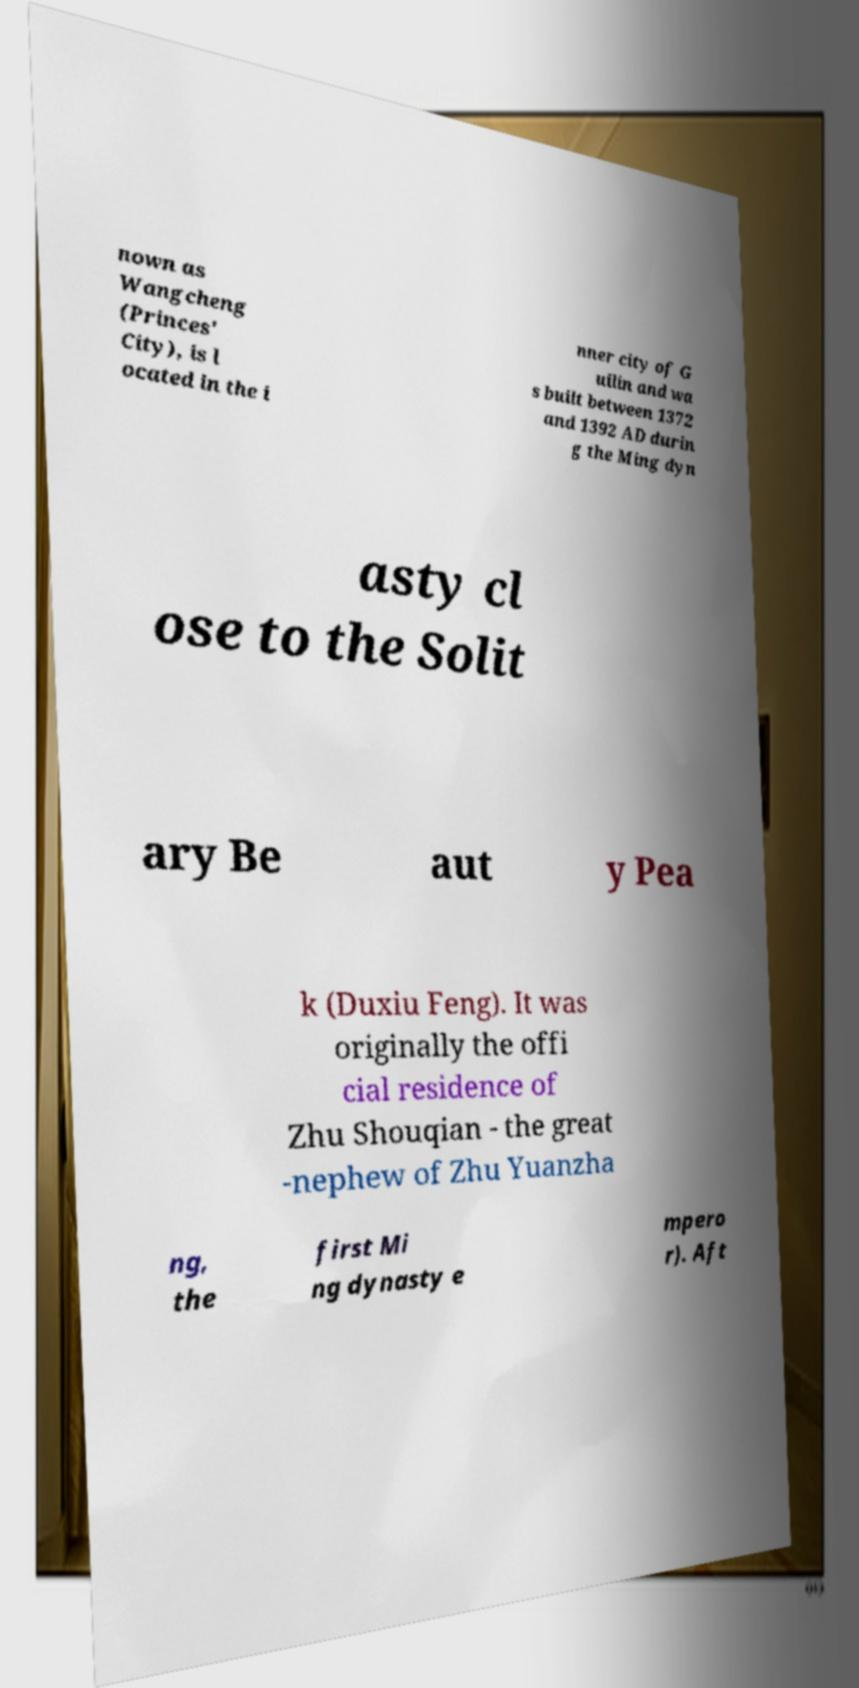There's text embedded in this image that I need extracted. Can you transcribe it verbatim? nown as Wangcheng (Princes' City), is l ocated in the i nner city of G uilin and wa s built between 1372 and 1392 AD durin g the Ming dyn asty cl ose to the Solit ary Be aut y Pea k (Duxiu Feng). It was originally the offi cial residence of Zhu Shouqian - the great -nephew of Zhu Yuanzha ng, the first Mi ng dynasty e mpero r). Aft 